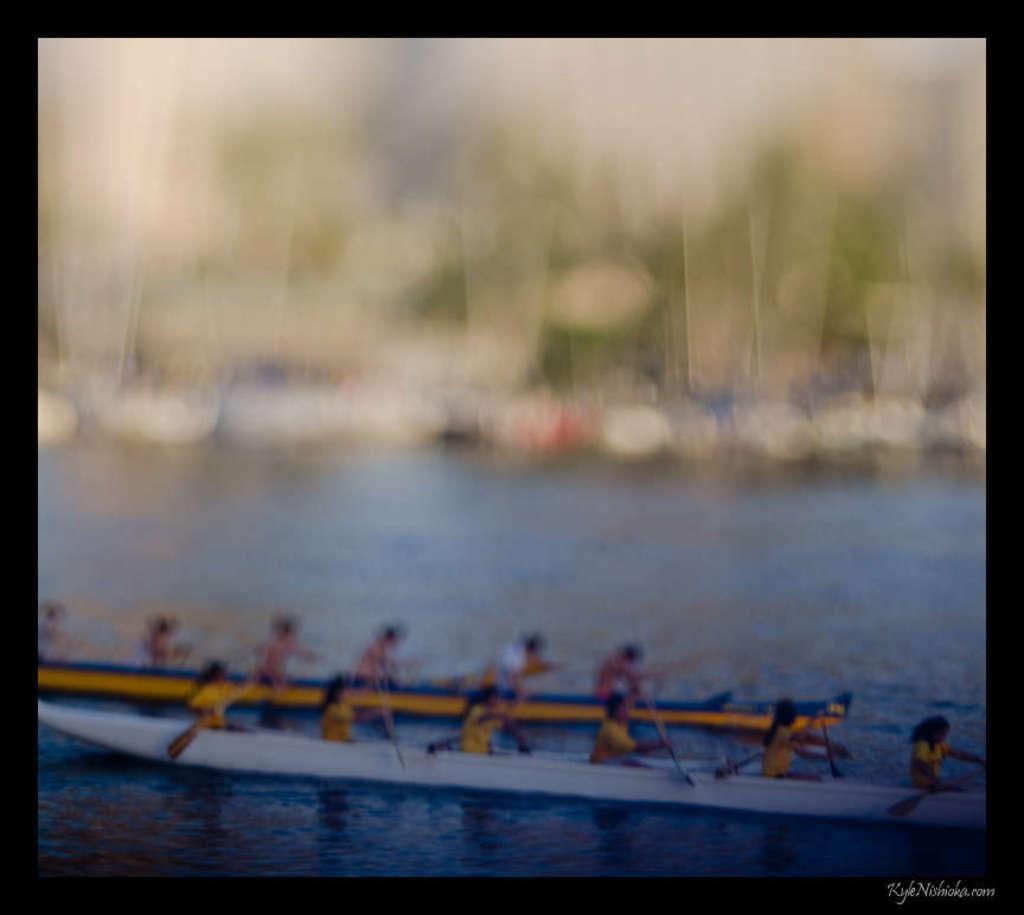Could you give a brief overview of what you see in this image? In this image I can see water and in it I can see few boats. I can also see number of people and I can see all of them are holding paddles. I can also see this image is little bit blurry. 